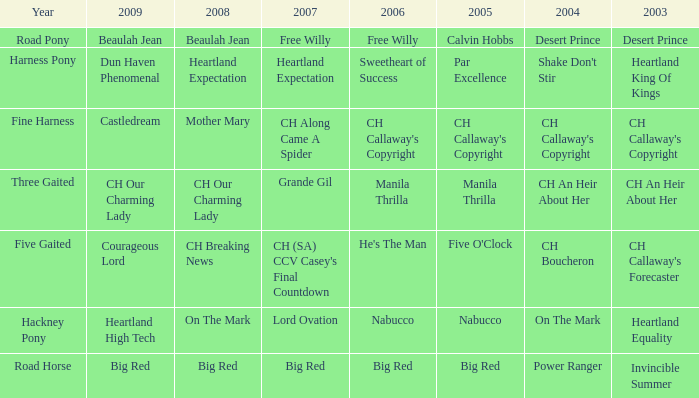Can you parse all the data within this table? {'header': ['Year', '2009', '2008', '2007', '2006', '2005', '2004', '2003'], 'rows': [['Road Pony', 'Beaulah Jean', 'Beaulah Jean', 'Free Willy', 'Free Willy', 'Calvin Hobbs', 'Desert Prince', 'Desert Prince'], ['Harness Pony', 'Dun Haven Phenomenal', 'Heartland Expectation', 'Heartland Expectation', 'Sweetheart of Success', 'Par Excellence', "Shake Don't Stir", 'Heartland King Of Kings'], ['Fine Harness', 'Castledream', 'Mother Mary', 'CH Along Came A Spider', "CH Callaway's Copyright", "CH Callaway's Copyright", "CH Callaway's Copyright", "CH Callaway's Copyright"], ['Three Gaited', 'CH Our Charming Lady', 'CH Our Charming Lady', 'Grande Gil', 'Manila Thrilla', 'Manila Thrilla', 'CH An Heir About Her', 'CH An Heir About Her'], ['Five Gaited', 'Courageous Lord', 'CH Breaking News', "CH (SA) CCV Casey's Final Countdown", "He's The Man", "Five O'Clock", 'CH Boucheron', "CH Callaway's Forecaster"], ['Hackney Pony', 'Heartland High Tech', 'On The Mark', 'Lord Ovation', 'Nabucco', 'Nabucco', 'On The Mark', 'Heartland Equality'], ['Road Horse', 'Big Red', 'Big Red', 'Big Red', 'Big Red', 'Big Red', 'Power Ranger', 'Invincible Summer']]} What year is the 2004 shake don't stir? Harness Pony. 